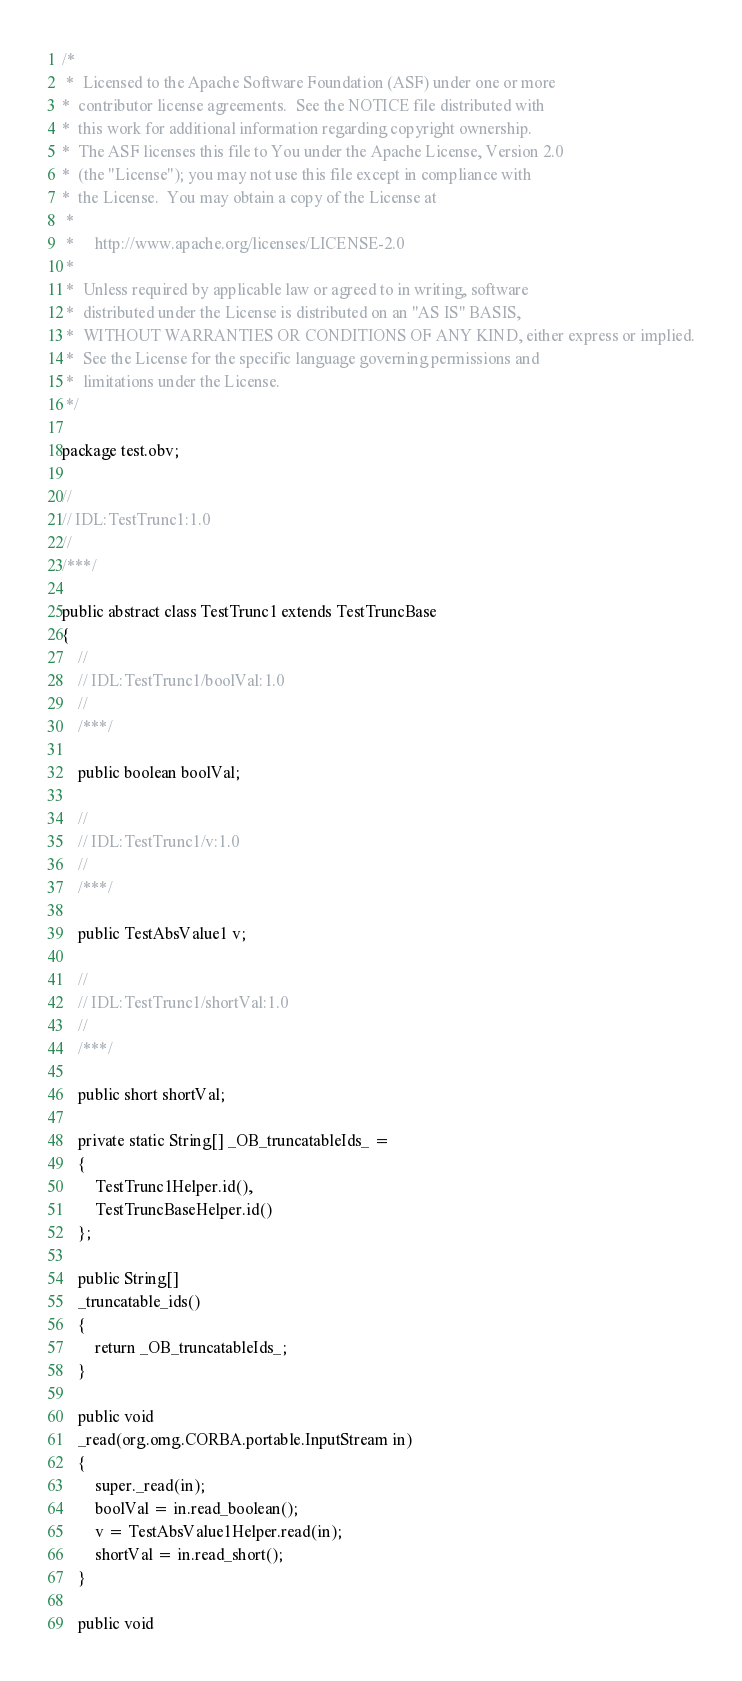Convert code to text. <code><loc_0><loc_0><loc_500><loc_500><_Java_>/*
 *  Licensed to the Apache Software Foundation (ASF) under one or more
*  contributor license agreements.  See the NOTICE file distributed with
*  this work for additional information regarding copyright ownership.
*  The ASF licenses this file to You under the Apache License, Version 2.0
*  (the "License"); you may not use this file except in compliance with
*  the License.  You may obtain a copy of the License at
 *
 *     http://www.apache.org/licenses/LICENSE-2.0
 *
 *  Unless required by applicable law or agreed to in writing, software
 *  distributed under the License is distributed on an "AS IS" BASIS,
 *  WITHOUT WARRANTIES OR CONDITIONS OF ANY KIND, either express or implied.
 *  See the License for the specific language governing permissions and
 *  limitations under the License.
 */

package test.obv;

//
// IDL:TestTrunc1:1.0
//
/***/

public abstract class TestTrunc1 extends TestTruncBase
{
    //
    // IDL:TestTrunc1/boolVal:1.0
    //
    /***/

    public boolean boolVal;

    //
    // IDL:TestTrunc1/v:1.0
    //
    /***/

    public TestAbsValue1 v;

    //
    // IDL:TestTrunc1/shortVal:1.0
    //
    /***/

    public short shortVal;

    private static String[] _OB_truncatableIds_ =
    {
        TestTrunc1Helper.id(),
        TestTruncBaseHelper.id()
    };

    public String[]
    _truncatable_ids()
    {
        return _OB_truncatableIds_;
    }

    public void
    _read(org.omg.CORBA.portable.InputStream in)
    {
        super._read(in);
        boolVal = in.read_boolean();
        v = TestAbsValue1Helper.read(in);
        shortVal = in.read_short();
    }

    public void</code> 